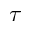<formula> <loc_0><loc_0><loc_500><loc_500>\tau</formula> 